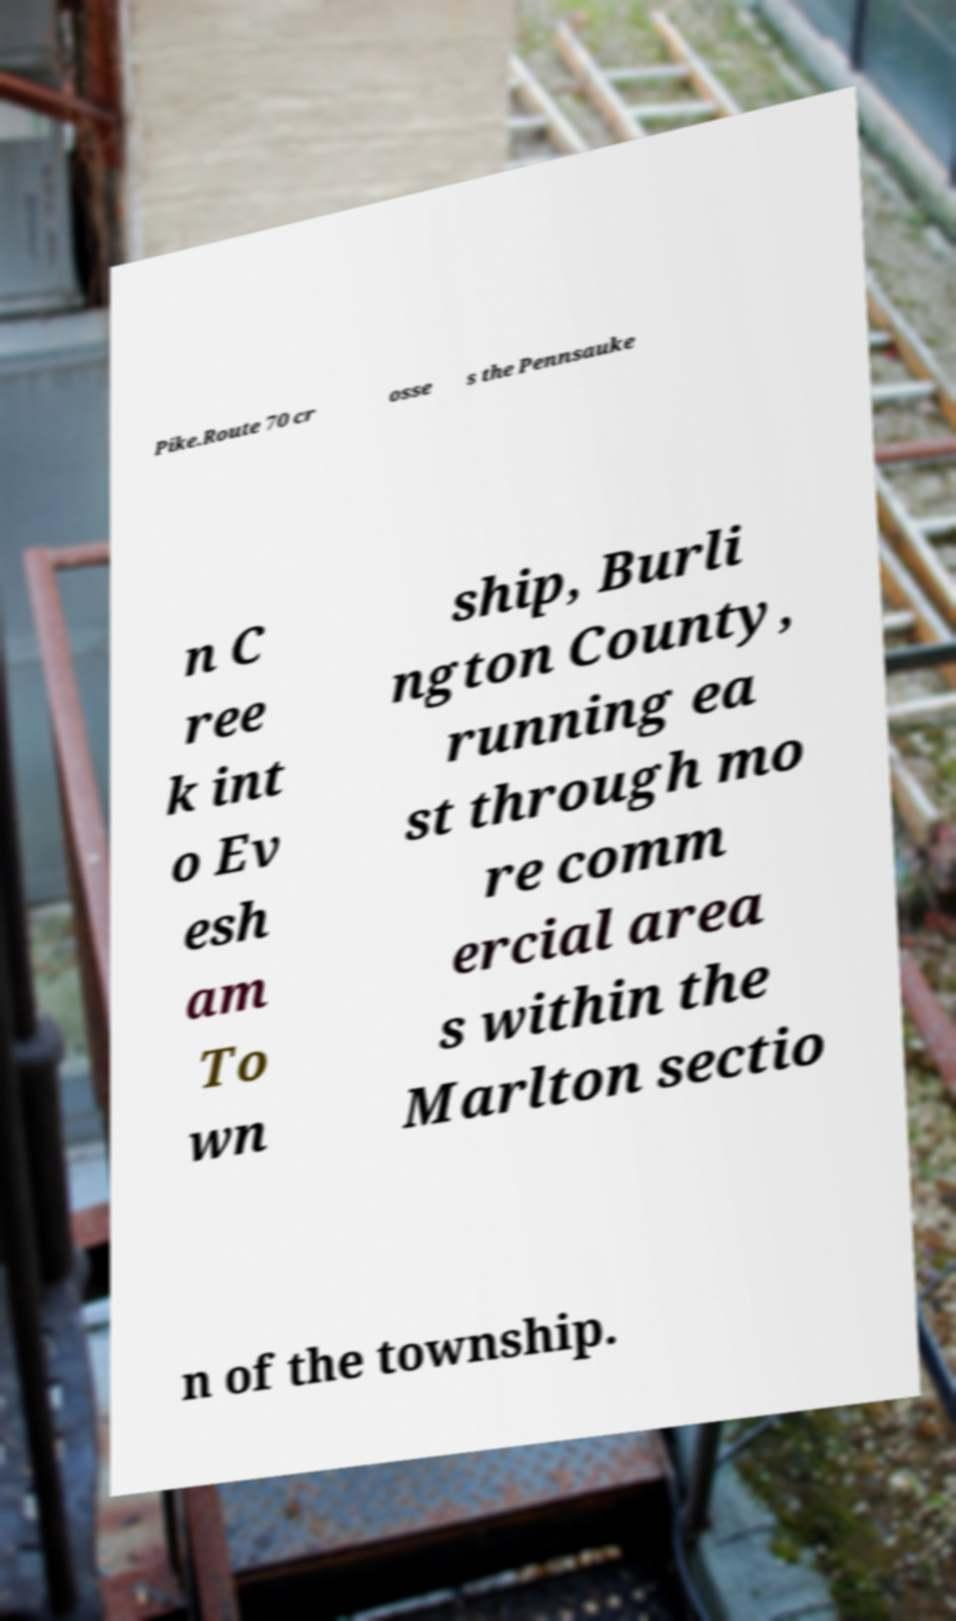For documentation purposes, I need the text within this image transcribed. Could you provide that? Pike.Route 70 cr osse s the Pennsauke n C ree k int o Ev esh am To wn ship, Burli ngton County, running ea st through mo re comm ercial area s within the Marlton sectio n of the township. 